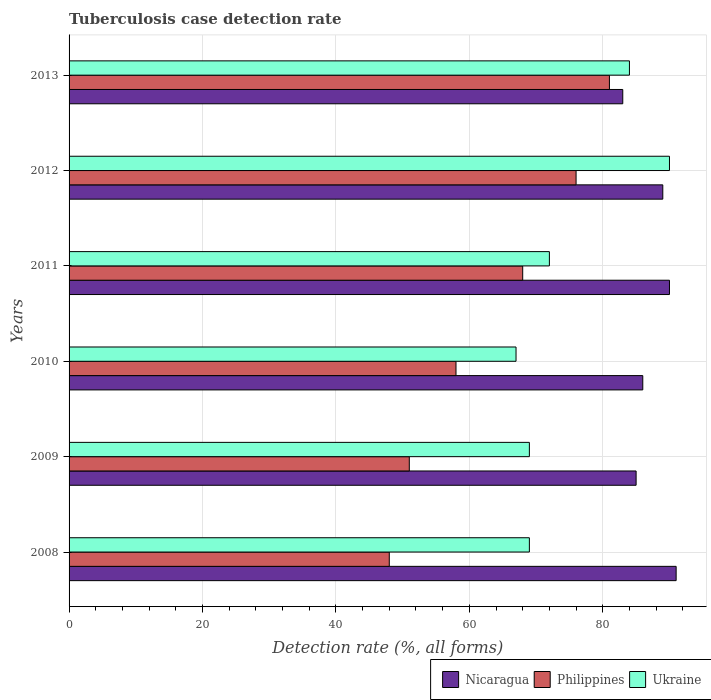How many different coloured bars are there?
Provide a succinct answer. 3. How many groups of bars are there?
Offer a very short reply. 6. Are the number of bars per tick equal to the number of legend labels?
Keep it short and to the point. Yes. Are the number of bars on each tick of the Y-axis equal?
Offer a very short reply. Yes. What is the tuberculosis case detection rate in in Nicaragua in 2008?
Ensure brevity in your answer.  91. Across all years, what is the maximum tuberculosis case detection rate in in Ukraine?
Your response must be concise. 90. Across all years, what is the minimum tuberculosis case detection rate in in Ukraine?
Your answer should be compact. 67. In which year was the tuberculosis case detection rate in in Ukraine minimum?
Provide a succinct answer. 2010. What is the total tuberculosis case detection rate in in Philippines in the graph?
Offer a terse response. 382. What is the difference between the tuberculosis case detection rate in in Philippines in 2012 and that in 2013?
Ensure brevity in your answer.  -5. What is the difference between the tuberculosis case detection rate in in Nicaragua in 2009 and the tuberculosis case detection rate in in Ukraine in 2012?
Provide a short and direct response. -5. What is the average tuberculosis case detection rate in in Nicaragua per year?
Your answer should be compact. 87.33. In the year 2013, what is the difference between the tuberculosis case detection rate in in Nicaragua and tuberculosis case detection rate in in Ukraine?
Give a very brief answer. -1. What is the ratio of the tuberculosis case detection rate in in Ukraine in 2008 to that in 2009?
Give a very brief answer. 1. What is the difference between the highest and the second highest tuberculosis case detection rate in in Philippines?
Your answer should be very brief. 5. What is the difference between the highest and the lowest tuberculosis case detection rate in in Ukraine?
Offer a very short reply. 23. Is the sum of the tuberculosis case detection rate in in Philippines in 2012 and 2013 greater than the maximum tuberculosis case detection rate in in Nicaragua across all years?
Your response must be concise. Yes. What does the 3rd bar from the top in 2009 represents?
Offer a terse response. Nicaragua. What does the 3rd bar from the bottom in 2010 represents?
Ensure brevity in your answer.  Ukraine. Is it the case that in every year, the sum of the tuberculosis case detection rate in in Nicaragua and tuberculosis case detection rate in in Ukraine is greater than the tuberculosis case detection rate in in Philippines?
Offer a terse response. Yes. How many years are there in the graph?
Provide a succinct answer. 6. Are the values on the major ticks of X-axis written in scientific E-notation?
Your response must be concise. No. Where does the legend appear in the graph?
Your answer should be very brief. Bottom right. How are the legend labels stacked?
Offer a very short reply. Horizontal. What is the title of the graph?
Your answer should be very brief. Tuberculosis case detection rate. Does "Serbia" appear as one of the legend labels in the graph?
Your answer should be compact. No. What is the label or title of the X-axis?
Your answer should be very brief. Detection rate (%, all forms). What is the Detection rate (%, all forms) in Nicaragua in 2008?
Provide a short and direct response. 91. What is the Detection rate (%, all forms) in Ukraine in 2008?
Keep it short and to the point. 69. What is the Detection rate (%, all forms) in Philippines in 2009?
Offer a terse response. 51. What is the Detection rate (%, all forms) in Ukraine in 2009?
Make the answer very short. 69. What is the Detection rate (%, all forms) of Ukraine in 2010?
Give a very brief answer. 67. What is the Detection rate (%, all forms) of Nicaragua in 2012?
Offer a very short reply. 89. What is the Detection rate (%, all forms) in Philippines in 2012?
Keep it short and to the point. 76. What is the Detection rate (%, all forms) in Nicaragua in 2013?
Provide a succinct answer. 83. What is the Detection rate (%, all forms) in Philippines in 2013?
Keep it short and to the point. 81. Across all years, what is the maximum Detection rate (%, all forms) in Nicaragua?
Ensure brevity in your answer.  91. Across all years, what is the maximum Detection rate (%, all forms) in Ukraine?
Offer a very short reply. 90. Across all years, what is the minimum Detection rate (%, all forms) of Philippines?
Offer a very short reply. 48. Across all years, what is the minimum Detection rate (%, all forms) in Ukraine?
Your answer should be compact. 67. What is the total Detection rate (%, all forms) in Nicaragua in the graph?
Provide a succinct answer. 524. What is the total Detection rate (%, all forms) in Philippines in the graph?
Offer a very short reply. 382. What is the total Detection rate (%, all forms) of Ukraine in the graph?
Offer a very short reply. 451. What is the difference between the Detection rate (%, all forms) of Nicaragua in 2008 and that in 2009?
Provide a short and direct response. 6. What is the difference between the Detection rate (%, all forms) in Philippines in 2008 and that in 2009?
Make the answer very short. -3. What is the difference between the Detection rate (%, all forms) in Ukraine in 2008 and that in 2009?
Offer a very short reply. 0. What is the difference between the Detection rate (%, all forms) in Ukraine in 2008 and that in 2010?
Give a very brief answer. 2. What is the difference between the Detection rate (%, all forms) in Nicaragua in 2008 and that in 2011?
Ensure brevity in your answer.  1. What is the difference between the Detection rate (%, all forms) of Ukraine in 2008 and that in 2011?
Provide a short and direct response. -3. What is the difference between the Detection rate (%, all forms) of Ukraine in 2008 and that in 2012?
Your answer should be very brief. -21. What is the difference between the Detection rate (%, all forms) of Philippines in 2008 and that in 2013?
Offer a very short reply. -33. What is the difference between the Detection rate (%, all forms) in Ukraine in 2008 and that in 2013?
Provide a short and direct response. -15. What is the difference between the Detection rate (%, all forms) in Nicaragua in 2009 and that in 2011?
Ensure brevity in your answer.  -5. What is the difference between the Detection rate (%, all forms) of Philippines in 2009 and that in 2011?
Your answer should be very brief. -17. What is the difference between the Detection rate (%, all forms) in Nicaragua in 2009 and that in 2012?
Provide a succinct answer. -4. What is the difference between the Detection rate (%, all forms) of Ukraine in 2009 and that in 2013?
Provide a succinct answer. -15. What is the difference between the Detection rate (%, all forms) in Philippines in 2010 and that in 2011?
Offer a terse response. -10. What is the difference between the Detection rate (%, all forms) in Philippines in 2010 and that in 2012?
Give a very brief answer. -18. What is the difference between the Detection rate (%, all forms) of Nicaragua in 2010 and that in 2013?
Your answer should be compact. 3. What is the difference between the Detection rate (%, all forms) of Nicaragua in 2011 and that in 2012?
Your answer should be very brief. 1. What is the difference between the Detection rate (%, all forms) in Ukraine in 2011 and that in 2012?
Offer a terse response. -18. What is the difference between the Detection rate (%, all forms) in Nicaragua in 2012 and that in 2013?
Your response must be concise. 6. What is the difference between the Detection rate (%, all forms) in Philippines in 2012 and that in 2013?
Provide a succinct answer. -5. What is the difference between the Detection rate (%, all forms) of Nicaragua in 2008 and the Detection rate (%, all forms) of Philippines in 2009?
Your answer should be compact. 40. What is the difference between the Detection rate (%, all forms) of Nicaragua in 2008 and the Detection rate (%, all forms) of Ukraine in 2009?
Provide a succinct answer. 22. What is the difference between the Detection rate (%, all forms) of Philippines in 2008 and the Detection rate (%, all forms) of Ukraine in 2009?
Your response must be concise. -21. What is the difference between the Detection rate (%, all forms) in Nicaragua in 2008 and the Detection rate (%, all forms) in Philippines in 2010?
Provide a succinct answer. 33. What is the difference between the Detection rate (%, all forms) in Nicaragua in 2008 and the Detection rate (%, all forms) in Ukraine in 2010?
Provide a short and direct response. 24. What is the difference between the Detection rate (%, all forms) in Nicaragua in 2008 and the Detection rate (%, all forms) in Philippines in 2011?
Keep it short and to the point. 23. What is the difference between the Detection rate (%, all forms) of Nicaragua in 2008 and the Detection rate (%, all forms) of Ukraine in 2011?
Give a very brief answer. 19. What is the difference between the Detection rate (%, all forms) in Nicaragua in 2008 and the Detection rate (%, all forms) in Ukraine in 2012?
Make the answer very short. 1. What is the difference between the Detection rate (%, all forms) of Philippines in 2008 and the Detection rate (%, all forms) of Ukraine in 2012?
Give a very brief answer. -42. What is the difference between the Detection rate (%, all forms) of Nicaragua in 2008 and the Detection rate (%, all forms) of Philippines in 2013?
Provide a succinct answer. 10. What is the difference between the Detection rate (%, all forms) of Nicaragua in 2008 and the Detection rate (%, all forms) of Ukraine in 2013?
Provide a succinct answer. 7. What is the difference between the Detection rate (%, all forms) of Philippines in 2008 and the Detection rate (%, all forms) of Ukraine in 2013?
Your answer should be very brief. -36. What is the difference between the Detection rate (%, all forms) of Nicaragua in 2009 and the Detection rate (%, all forms) of Philippines in 2011?
Offer a terse response. 17. What is the difference between the Detection rate (%, all forms) of Nicaragua in 2009 and the Detection rate (%, all forms) of Ukraine in 2011?
Ensure brevity in your answer.  13. What is the difference between the Detection rate (%, all forms) in Nicaragua in 2009 and the Detection rate (%, all forms) in Ukraine in 2012?
Your answer should be compact. -5. What is the difference between the Detection rate (%, all forms) in Philippines in 2009 and the Detection rate (%, all forms) in Ukraine in 2012?
Ensure brevity in your answer.  -39. What is the difference between the Detection rate (%, all forms) in Nicaragua in 2009 and the Detection rate (%, all forms) in Philippines in 2013?
Provide a short and direct response. 4. What is the difference between the Detection rate (%, all forms) of Philippines in 2009 and the Detection rate (%, all forms) of Ukraine in 2013?
Make the answer very short. -33. What is the difference between the Detection rate (%, all forms) in Philippines in 2010 and the Detection rate (%, all forms) in Ukraine in 2011?
Offer a terse response. -14. What is the difference between the Detection rate (%, all forms) of Philippines in 2010 and the Detection rate (%, all forms) of Ukraine in 2012?
Your answer should be compact. -32. What is the difference between the Detection rate (%, all forms) in Nicaragua in 2010 and the Detection rate (%, all forms) in Philippines in 2013?
Give a very brief answer. 5. What is the difference between the Detection rate (%, all forms) in Nicaragua in 2010 and the Detection rate (%, all forms) in Ukraine in 2013?
Offer a terse response. 2. What is the difference between the Detection rate (%, all forms) of Philippines in 2010 and the Detection rate (%, all forms) of Ukraine in 2013?
Provide a succinct answer. -26. What is the difference between the Detection rate (%, all forms) of Nicaragua in 2011 and the Detection rate (%, all forms) of Philippines in 2012?
Offer a very short reply. 14. What is the difference between the Detection rate (%, all forms) of Nicaragua in 2011 and the Detection rate (%, all forms) of Ukraine in 2013?
Offer a very short reply. 6. What is the average Detection rate (%, all forms) of Nicaragua per year?
Make the answer very short. 87.33. What is the average Detection rate (%, all forms) of Philippines per year?
Your response must be concise. 63.67. What is the average Detection rate (%, all forms) of Ukraine per year?
Your answer should be very brief. 75.17. In the year 2008, what is the difference between the Detection rate (%, all forms) in Nicaragua and Detection rate (%, all forms) in Philippines?
Ensure brevity in your answer.  43. In the year 2009, what is the difference between the Detection rate (%, all forms) of Nicaragua and Detection rate (%, all forms) of Ukraine?
Provide a short and direct response. 16. In the year 2009, what is the difference between the Detection rate (%, all forms) in Philippines and Detection rate (%, all forms) in Ukraine?
Your response must be concise. -18. In the year 2010, what is the difference between the Detection rate (%, all forms) in Nicaragua and Detection rate (%, all forms) in Philippines?
Your response must be concise. 28. In the year 2010, what is the difference between the Detection rate (%, all forms) in Nicaragua and Detection rate (%, all forms) in Ukraine?
Your answer should be compact. 19. In the year 2010, what is the difference between the Detection rate (%, all forms) of Philippines and Detection rate (%, all forms) of Ukraine?
Keep it short and to the point. -9. In the year 2011, what is the difference between the Detection rate (%, all forms) in Nicaragua and Detection rate (%, all forms) in Philippines?
Keep it short and to the point. 22. In the year 2012, what is the difference between the Detection rate (%, all forms) in Nicaragua and Detection rate (%, all forms) in Ukraine?
Make the answer very short. -1. What is the ratio of the Detection rate (%, all forms) of Nicaragua in 2008 to that in 2009?
Ensure brevity in your answer.  1.07. What is the ratio of the Detection rate (%, all forms) in Nicaragua in 2008 to that in 2010?
Ensure brevity in your answer.  1.06. What is the ratio of the Detection rate (%, all forms) in Philippines in 2008 to that in 2010?
Offer a terse response. 0.83. What is the ratio of the Detection rate (%, all forms) of Ukraine in 2008 to that in 2010?
Give a very brief answer. 1.03. What is the ratio of the Detection rate (%, all forms) in Nicaragua in 2008 to that in 2011?
Your answer should be very brief. 1.01. What is the ratio of the Detection rate (%, all forms) of Philippines in 2008 to that in 2011?
Ensure brevity in your answer.  0.71. What is the ratio of the Detection rate (%, all forms) in Nicaragua in 2008 to that in 2012?
Offer a very short reply. 1.02. What is the ratio of the Detection rate (%, all forms) in Philippines in 2008 to that in 2012?
Your answer should be very brief. 0.63. What is the ratio of the Detection rate (%, all forms) of Ukraine in 2008 to that in 2012?
Your response must be concise. 0.77. What is the ratio of the Detection rate (%, all forms) in Nicaragua in 2008 to that in 2013?
Your response must be concise. 1.1. What is the ratio of the Detection rate (%, all forms) of Philippines in 2008 to that in 2013?
Provide a short and direct response. 0.59. What is the ratio of the Detection rate (%, all forms) in Ukraine in 2008 to that in 2013?
Your answer should be very brief. 0.82. What is the ratio of the Detection rate (%, all forms) of Nicaragua in 2009 to that in 2010?
Provide a short and direct response. 0.99. What is the ratio of the Detection rate (%, all forms) of Philippines in 2009 to that in 2010?
Ensure brevity in your answer.  0.88. What is the ratio of the Detection rate (%, all forms) of Ukraine in 2009 to that in 2010?
Ensure brevity in your answer.  1.03. What is the ratio of the Detection rate (%, all forms) in Nicaragua in 2009 to that in 2011?
Offer a very short reply. 0.94. What is the ratio of the Detection rate (%, all forms) of Philippines in 2009 to that in 2011?
Your answer should be compact. 0.75. What is the ratio of the Detection rate (%, all forms) in Ukraine in 2009 to that in 2011?
Give a very brief answer. 0.96. What is the ratio of the Detection rate (%, all forms) in Nicaragua in 2009 to that in 2012?
Your response must be concise. 0.96. What is the ratio of the Detection rate (%, all forms) of Philippines in 2009 to that in 2012?
Offer a very short reply. 0.67. What is the ratio of the Detection rate (%, all forms) of Ukraine in 2009 to that in 2012?
Offer a terse response. 0.77. What is the ratio of the Detection rate (%, all forms) in Nicaragua in 2009 to that in 2013?
Your answer should be very brief. 1.02. What is the ratio of the Detection rate (%, all forms) in Philippines in 2009 to that in 2013?
Offer a terse response. 0.63. What is the ratio of the Detection rate (%, all forms) of Ukraine in 2009 to that in 2013?
Ensure brevity in your answer.  0.82. What is the ratio of the Detection rate (%, all forms) of Nicaragua in 2010 to that in 2011?
Make the answer very short. 0.96. What is the ratio of the Detection rate (%, all forms) in Philippines in 2010 to that in 2011?
Your answer should be very brief. 0.85. What is the ratio of the Detection rate (%, all forms) of Ukraine in 2010 to that in 2011?
Keep it short and to the point. 0.93. What is the ratio of the Detection rate (%, all forms) in Nicaragua in 2010 to that in 2012?
Offer a very short reply. 0.97. What is the ratio of the Detection rate (%, all forms) in Philippines in 2010 to that in 2012?
Your answer should be compact. 0.76. What is the ratio of the Detection rate (%, all forms) in Ukraine in 2010 to that in 2012?
Ensure brevity in your answer.  0.74. What is the ratio of the Detection rate (%, all forms) in Nicaragua in 2010 to that in 2013?
Offer a very short reply. 1.04. What is the ratio of the Detection rate (%, all forms) in Philippines in 2010 to that in 2013?
Your response must be concise. 0.72. What is the ratio of the Detection rate (%, all forms) of Ukraine in 2010 to that in 2013?
Offer a very short reply. 0.8. What is the ratio of the Detection rate (%, all forms) of Nicaragua in 2011 to that in 2012?
Keep it short and to the point. 1.01. What is the ratio of the Detection rate (%, all forms) of Philippines in 2011 to that in 2012?
Provide a succinct answer. 0.89. What is the ratio of the Detection rate (%, all forms) in Nicaragua in 2011 to that in 2013?
Give a very brief answer. 1.08. What is the ratio of the Detection rate (%, all forms) in Philippines in 2011 to that in 2013?
Your answer should be very brief. 0.84. What is the ratio of the Detection rate (%, all forms) of Nicaragua in 2012 to that in 2013?
Give a very brief answer. 1.07. What is the ratio of the Detection rate (%, all forms) of Philippines in 2012 to that in 2013?
Provide a succinct answer. 0.94. What is the ratio of the Detection rate (%, all forms) in Ukraine in 2012 to that in 2013?
Offer a very short reply. 1.07. What is the difference between the highest and the second highest Detection rate (%, all forms) of Nicaragua?
Keep it short and to the point. 1. What is the difference between the highest and the second highest Detection rate (%, all forms) in Ukraine?
Offer a very short reply. 6. What is the difference between the highest and the lowest Detection rate (%, all forms) of Nicaragua?
Offer a very short reply. 8. What is the difference between the highest and the lowest Detection rate (%, all forms) in Philippines?
Your answer should be compact. 33. 